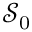Convert formula to latex. <formula><loc_0><loc_0><loc_500><loc_500>{ \mathcal { S } } _ { 0 }</formula> 